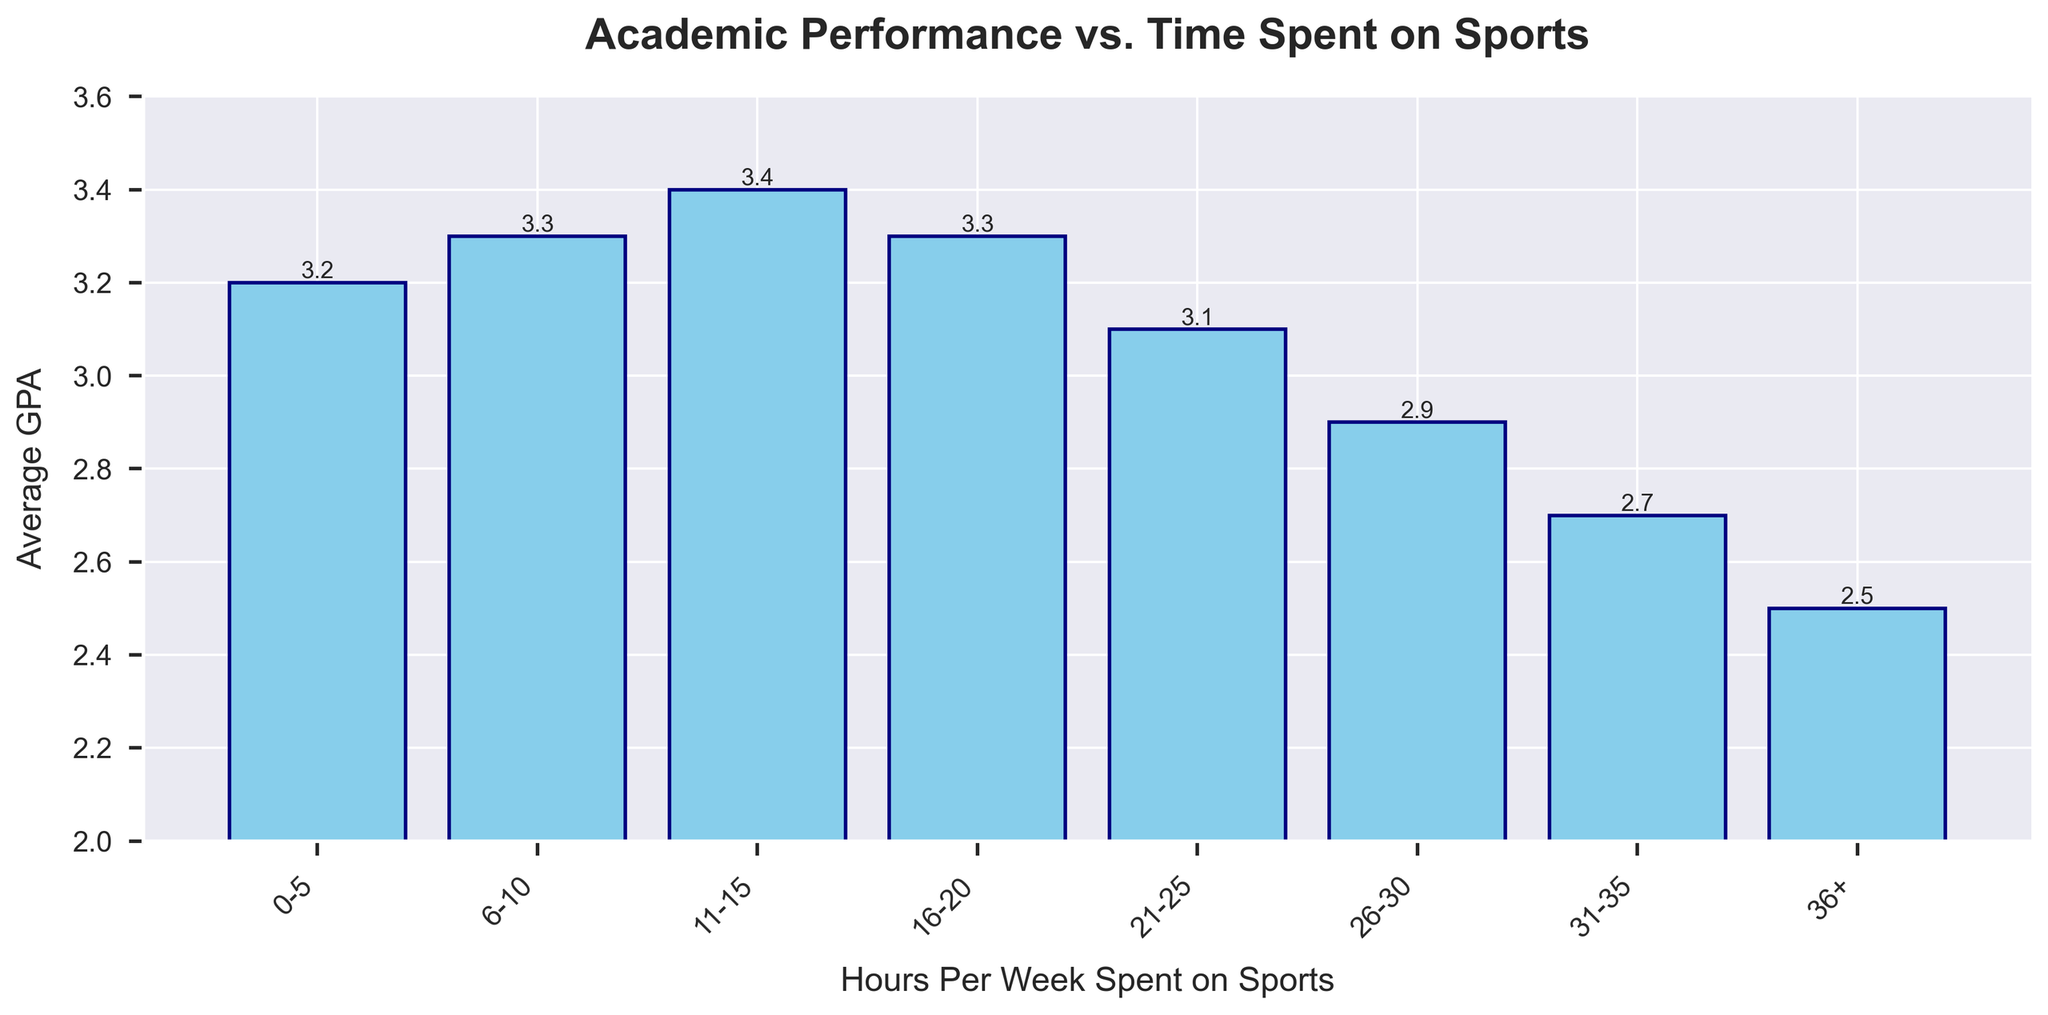How many GPA categories show a GPA higher than 3.0? There are 8 GPA categories shown on the bar graph. By looking at the height of the bars, there are 5 categories where the GPA is above 3.0: 0-5, 6-10, 11-15, 16-20, and 21-25 hours per week.
Answer: 5 Which range of hours spent on sports has the highest average GPA? By observing the height of the bars, the highest bar corresponds to the 11-15 hours/week category, with an average GPA of 3.4.
Answer: 11-15 hours/week How does the average GPA change if you consider more than 25 hours/week on sports? From the figure, comparing the GPA of categories 26-30, 31-35, and 36+ hours per week: the average GPA decreases from 2.9, to 2.7, and finally to 2.5. Thus, the GPA consistently drops as the hours spent on sports exceed 25 hours/week.
Answer: It decreases What is the difference in GPA between spending 0-5 hours per week and 36+ hours per week on sports? The average GPA for 0-5 hours/week is 3.2 and for 36+ hours/week it is 2.5. The difference is calculated as 3.2 - 2.5 = 0.7.
Answer: 0.7 Is there a negative trend in the average GPA when students spend more than 15 hours per week on sports? Looking at the graph, the GPAs from categories 16-20, 21-25, 26-30, 31-35, and 36+ hours per week are 3.3, 3.1, 2.9, 2.7, and 2.5 respectively, displaying a decreasing trend as the hours increase beyond 15 hours.
Answer: Yes Which two consecutive categories have the biggest drop in average GPA? By comparing the difference between consecutive categories, the largest drop is between 0-5 hours/week (3.2 GPA) and 36+ hours/week (2.5 GPA), which is a 0.7 difference.
Answer: 0-5 and 36+ hours/week What are the visual indicators that show which range of hours spent on sports is associated with a GPA close to 3.0? The visual indicators to consider include the bar heights and the GPA values labeled above each bar. The 21-25 hours/week category has a bar indicating a GPA of 3.1, which is close to 3.0.
Answer: 21-25 hours/week Between which two categories does the average GPA first decrease? Observing the bars starting from the lowest to the highest hours per week, the first decrease appears between the 0-5 hours/week (3.2 GPA) and 21-25 hours/week (3.1 GPA) categories.
Answer: 0-5 and 21-25 hours/week 